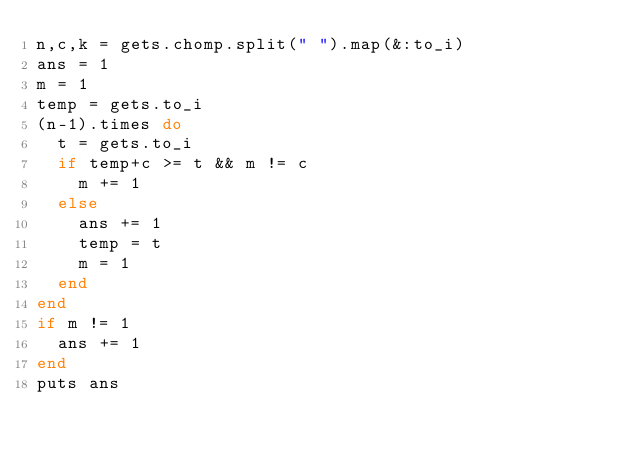<code> <loc_0><loc_0><loc_500><loc_500><_Ruby_>n,c,k = gets.chomp.split(" ").map(&:to_i)
ans = 1
m = 1
temp = gets.to_i
(n-1).times do
  t = gets.to_i
  if temp+c >= t && m != c
    m += 1
  else
    ans += 1
    temp = t
    m = 1
  end
end
if m != 1
  ans += 1
end
puts ans</code> 